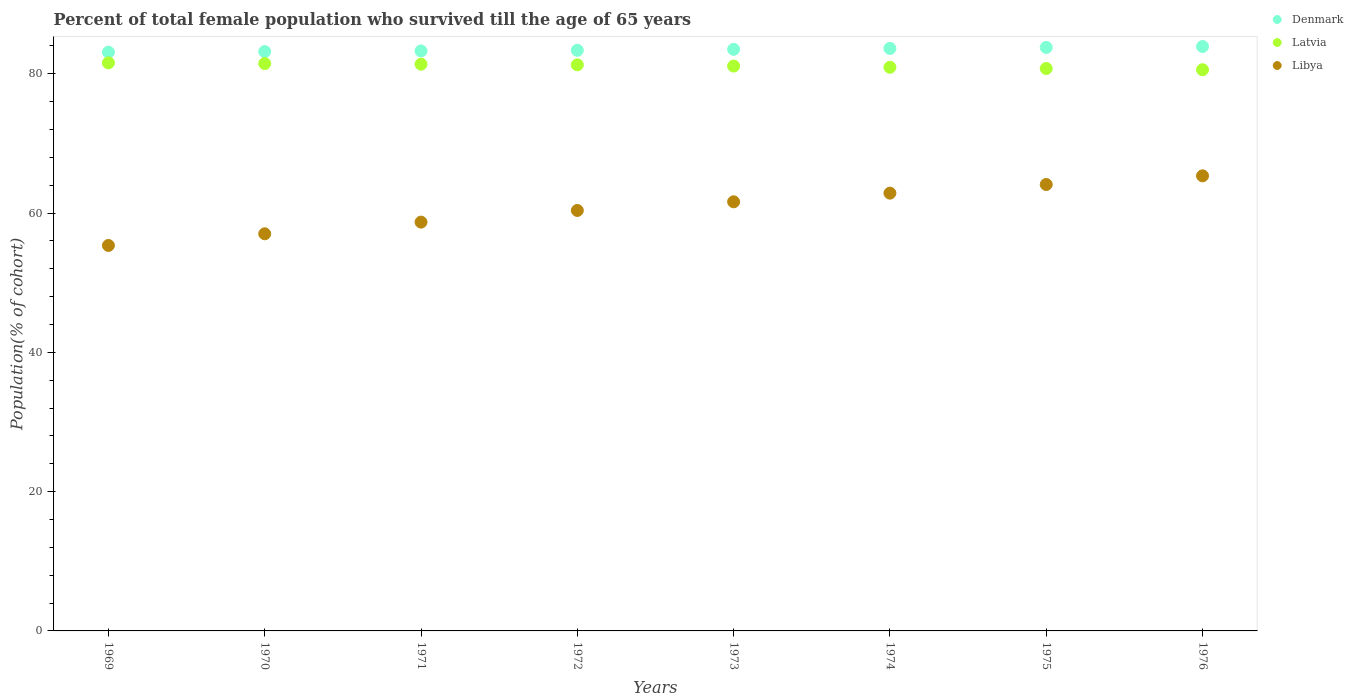What is the percentage of total female population who survived till the age of 65 years in Libya in 1971?
Offer a terse response. 58.71. Across all years, what is the maximum percentage of total female population who survived till the age of 65 years in Libya?
Provide a short and direct response. 65.35. Across all years, what is the minimum percentage of total female population who survived till the age of 65 years in Denmark?
Provide a succinct answer. 83.11. In which year was the percentage of total female population who survived till the age of 65 years in Latvia maximum?
Provide a succinct answer. 1969. In which year was the percentage of total female population who survived till the age of 65 years in Latvia minimum?
Your response must be concise. 1976. What is the total percentage of total female population who survived till the age of 65 years in Latvia in the graph?
Offer a terse response. 649.14. What is the difference between the percentage of total female population who survived till the age of 65 years in Denmark in 1974 and that in 1976?
Provide a succinct answer. -0.27. What is the difference between the percentage of total female population who survived till the age of 65 years in Latvia in 1972 and the percentage of total female population who survived till the age of 65 years in Denmark in 1970?
Your answer should be compact. -1.9. What is the average percentage of total female population who survived till the age of 65 years in Denmark per year?
Keep it short and to the point. 83.48. In the year 1973, what is the difference between the percentage of total female population who survived till the age of 65 years in Libya and percentage of total female population who survived till the age of 65 years in Denmark?
Offer a terse response. -21.89. What is the ratio of the percentage of total female population who survived till the age of 65 years in Denmark in 1973 to that in 1975?
Make the answer very short. 1. Is the percentage of total female population who survived till the age of 65 years in Denmark in 1969 less than that in 1970?
Your answer should be compact. Yes. Is the difference between the percentage of total female population who survived till the age of 65 years in Libya in 1972 and 1974 greater than the difference between the percentage of total female population who survived till the age of 65 years in Denmark in 1972 and 1974?
Ensure brevity in your answer.  No. What is the difference between the highest and the second highest percentage of total female population who survived till the age of 65 years in Denmark?
Offer a terse response. 0.14. What is the difference between the highest and the lowest percentage of total female population who survived till the age of 65 years in Denmark?
Provide a succinct answer. 0.82. In how many years, is the percentage of total female population who survived till the age of 65 years in Latvia greater than the average percentage of total female population who survived till the age of 65 years in Latvia taken over all years?
Make the answer very short. 4. Is the sum of the percentage of total female population who survived till the age of 65 years in Denmark in 1973 and 1974 greater than the maximum percentage of total female population who survived till the age of 65 years in Libya across all years?
Your answer should be compact. Yes. Does the percentage of total female population who survived till the age of 65 years in Libya monotonically increase over the years?
Make the answer very short. Yes. Is the percentage of total female population who survived till the age of 65 years in Latvia strictly less than the percentage of total female population who survived till the age of 65 years in Denmark over the years?
Offer a terse response. Yes. Are the values on the major ticks of Y-axis written in scientific E-notation?
Offer a terse response. No. Does the graph contain any zero values?
Ensure brevity in your answer.  No. Does the graph contain grids?
Ensure brevity in your answer.  No. How are the legend labels stacked?
Provide a short and direct response. Vertical. What is the title of the graph?
Offer a terse response. Percent of total female population who survived till the age of 65 years. Does "Cambodia" appear as one of the legend labels in the graph?
Your answer should be very brief. No. What is the label or title of the Y-axis?
Your answer should be very brief. Population(% of cohort). What is the Population(% of cohort) of Denmark in 1969?
Ensure brevity in your answer.  83.11. What is the Population(% of cohort) of Latvia in 1969?
Offer a terse response. 81.57. What is the Population(% of cohort) in Libya in 1969?
Keep it short and to the point. 55.36. What is the Population(% of cohort) of Denmark in 1970?
Provide a short and direct response. 83.2. What is the Population(% of cohort) in Latvia in 1970?
Offer a very short reply. 81.48. What is the Population(% of cohort) of Libya in 1970?
Offer a terse response. 57.03. What is the Population(% of cohort) of Denmark in 1971?
Offer a very short reply. 83.29. What is the Population(% of cohort) in Latvia in 1971?
Offer a terse response. 81.39. What is the Population(% of cohort) in Libya in 1971?
Keep it short and to the point. 58.71. What is the Population(% of cohort) in Denmark in 1972?
Provide a short and direct response. 83.38. What is the Population(% of cohort) of Latvia in 1972?
Your response must be concise. 81.29. What is the Population(% of cohort) of Libya in 1972?
Keep it short and to the point. 60.38. What is the Population(% of cohort) of Denmark in 1973?
Give a very brief answer. 83.52. What is the Population(% of cohort) in Latvia in 1973?
Your answer should be compact. 81.12. What is the Population(% of cohort) in Libya in 1973?
Offer a very short reply. 61.62. What is the Population(% of cohort) of Denmark in 1974?
Keep it short and to the point. 83.65. What is the Population(% of cohort) in Latvia in 1974?
Offer a very short reply. 80.94. What is the Population(% of cohort) in Libya in 1974?
Provide a short and direct response. 62.87. What is the Population(% of cohort) of Denmark in 1975?
Your answer should be compact. 83.79. What is the Population(% of cohort) of Latvia in 1975?
Offer a very short reply. 80.77. What is the Population(% of cohort) in Libya in 1975?
Offer a terse response. 64.11. What is the Population(% of cohort) of Denmark in 1976?
Your answer should be compact. 83.92. What is the Population(% of cohort) of Latvia in 1976?
Keep it short and to the point. 80.59. What is the Population(% of cohort) of Libya in 1976?
Provide a short and direct response. 65.35. Across all years, what is the maximum Population(% of cohort) of Denmark?
Your response must be concise. 83.92. Across all years, what is the maximum Population(% of cohort) of Latvia?
Offer a very short reply. 81.57. Across all years, what is the maximum Population(% of cohort) of Libya?
Offer a terse response. 65.35. Across all years, what is the minimum Population(% of cohort) in Denmark?
Ensure brevity in your answer.  83.11. Across all years, what is the minimum Population(% of cohort) of Latvia?
Provide a succinct answer. 80.59. Across all years, what is the minimum Population(% of cohort) of Libya?
Offer a very short reply. 55.36. What is the total Population(% of cohort) in Denmark in the graph?
Give a very brief answer. 667.85. What is the total Population(% of cohort) of Latvia in the graph?
Your response must be concise. 649.14. What is the total Population(% of cohort) in Libya in the graph?
Make the answer very short. 485.43. What is the difference between the Population(% of cohort) in Denmark in 1969 and that in 1970?
Keep it short and to the point. -0.09. What is the difference between the Population(% of cohort) of Latvia in 1969 and that in 1970?
Offer a very short reply. 0.09. What is the difference between the Population(% of cohort) in Libya in 1969 and that in 1970?
Make the answer very short. -1.68. What is the difference between the Population(% of cohort) in Denmark in 1969 and that in 1971?
Your answer should be very brief. -0.18. What is the difference between the Population(% of cohort) of Latvia in 1969 and that in 1971?
Your response must be concise. 0.19. What is the difference between the Population(% of cohort) in Libya in 1969 and that in 1971?
Provide a succinct answer. -3.35. What is the difference between the Population(% of cohort) of Denmark in 1969 and that in 1972?
Offer a terse response. -0.28. What is the difference between the Population(% of cohort) of Latvia in 1969 and that in 1972?
Ensure brevity in your answer.  0.28. What is the difference between the Population(% of cohort) in Libya in 1969 and that in 1972?
Your answer should be compact. -5.03. What is the difference between the Population(% of cohort) in Denmark in 1969 and that in 1973?
Your answer should be compact. -0.41. What is the difference between the Population(% of cohort) in Latvia in 1969 and that in 1973?
Provide a short and direct response. 0.45. What is the difference between the Population(% of cohort) in Libya in 1969 and that in 1973?
Make the answer very short. -6.27. What is the difference between the Population(% of cohort) of Denmark in 1969 and that in 1974?
Your response must be concise. -0.55. What is the difference between the Population(% of cohort) of Latvia in 1969 and that in 1974?
Ensure brevity in your answer.  0.63. What is the difference between the Population(% of cohort) in Libya in 1969 and that in 1974?
Ensure brevity in your answer.  -7.51. What is the difference between the Population(% of cohort) of Denmark in 1969 and that in 1975?
Offer a very short reply. -0.68. What is the difference between the Population(% of cohort) of Latvia in 1969 and that in 1975?
Keep it short and to the point. 0.8. What is the difference between the Population(% of cohort) in Libya in 1969 and that in 1975?
Make the answer very short. -8.75. What is the difference between the Population(% of cohort) of Denmark in 1969 and that in 1976?
Provide a short and direct response. -0.82. What is the difference between the Population(% of cohort) in Latvia in 1969 and that in 1976?
Make the answer very short. 0.98. What is the difference between the Population(% of cohort) of Libya in 1969 and that in 1976?
Provide a short and direct response. -10. What is the difference between the Population(% of cohort) of Denmark in 1970 and that in 1971?
Keep it short and to the point. -0.09. What is the difference between the Population(% of cohort) of Latvia in 1970 and that in 1971?
Offer a terse response. 0.09. What is the difference between the Population(% of cohort) in Libya in 1970 and that in 1971?
Ensure brevity in your answer.  -1.68. What is the difference between the Population(% of cohort) in Denmark in 1970 and that in 1972?
Your response must be concise. -0.18. What is the difference between the Population(% of cohort) in Latvia in 1970 and that in 1972?
Provide a short and direct response. 0.19. What is the difference between the Population(% of cohort) in Libya in 1970 and that in 1972?
Ensure brevity in your answer.  -3.35. What is the difference between the Population(% of cohort) of Denmark in 1970 and that in 1973?
Provide a short and direct response. -0.32. What is the difference between the Population(% of cohort) of Latvia in 1970 and that in 1973?
Ensure brevity in your answer.  0.36. What is the difference between the Population(% of cohort) of Libya in 1970 and that in 1973?
Your answer should be compact. -4.59. What is the difference between the Population(% of cohort) of Denmark in 1970 and that in 1974?
Your response must be concise. -0.46. What is the difference between the Population(% of cohort) of Latvia in 1970 and that in 1974?
Offer a terse response. 0.54. What is the difference between the Population(% of cohort) in Libya in 1970 and that in 1974?
Keep it short and to the point. -5.84. What is the difference between the Population(% of cohort) of Denmark in 1970 and that in 1975?
Provide a succinct answer. -0.59. What is the difference between the Population(% of cohort) in Latvia in 1970 and that in 1975?
Make the answer very short. 0.71. What is the difference between the Population(% of cohort) of Libya in 1970 and that in 1975?
Your answer should be very brief. -7.08. What is the difference between the Population(% of cohort) of Denmark in 1970 and that in 1976?
Provide a succinct answer. -0.73. What is the difference between the Population(% of cohort) of Latvia in 1970 and that in 1976?
Offer a very short reply. 0.89. What is the difference between the Population(% of cohort) in Libya in 1970 and that in 1976?
Make the answer very short. -8.32. What is the difference between the Population(% of cohort) of Denmark in 1971 and that in 1972?
Keep it short and to the point. -0.09. What is the difference between the Population(% of cohort) in Latvia in 1971 and that in 1972?
Ensure brevity in your answer.  0.09. What is the difference between the Population(% of cohort) in Libya in 1971 and that in 1972?
Give a very brief answer. -1.68. What is the difference between the Population(% of cohort) of Denmark in 1971 and that in 1973?
Ensure brevity in your answer.  -0.23. What is the difference between the Population(% of cohort) of Latvia in 1971 and that in 1973?
Your answer should be compact. 0.27. What is the difference between the Population(% of cohort) of Libya in 1971 and that in 1973?
Your answer should be very brief. -2.92. What is the difference between the Population(% of cohort) in Denmark in 1971 and that in 1974?
Your response must be concise. -0.36. What is the difference between the Population(% of cohort) of Latvia in 1971 and that in 1974?
Ensure brevity in your answer.  0.44. What is the difference between the Population(% of cohort) in Libya in 1971 and that in 1974?
Give a very brief answer. -4.16. What is the difference between the Population(% of cohort) in Denmark in 1971 and that in 1975?
Provide a short and direct response. -0.5. What is the difference between the Population(% of cohort) of Latvia in 1971 and that in 1975?
Offer a terse response. 0.62. What is the difference between the Population(% of cohort) of Libya in 1971 and that in 1975?
Make the answer very short. -5.4. What is the difference between the Population(% of cohort) of Denmark in 1971 and that in 1976?
Offer a very short reply. -0.63. What is the difference between the Population(% of cohort) in Latvia in 1971 and that in 1976?
Give a very brief answer. 0.79. What is the difference between the Population(% of cohort) in Libya in 1971 and that in 1976?
Give a very brief answer. -6.65. What is the difference between the Population(% of cohort) in Denmark in 1972 and that in 1973?
Your response must be concise. -0.14. What is the difference between the Population(% of cohort) in Latvia in 1972 and that in 1973?
Your response must be concise. 0.18. What is the difference between the Population(% of cohort) in Libya in 1972 and that in 1973?
Your response must be concise. -1.24. What is the difference between the Population(% of cohort) of Denmark in 1972 and that in 1974?
Give a very brief answer. -0.27. What is the difference between the Population(% of cohort) in Latvia in 1972 and that in 1974?
Provide a succinct answer. 0.35. What is the difference between the Population(% of cohort) of Libya in 1972 and that in 1974?
Keep it short and to the point. -2.49. What is the difference between the Population(% of cohort) of Denmark in 1972 and that in 1975?
Your answer should be very brief. -0.41. What is the difference between the Population(% of cohort) in Latvia in 1972 and that in 1975?
Your answer should be compact. 0.53. What is the difference between the Population(% of cohort) of Libya in 1972 and that in 1975?
Give a very brief answer. -3.73. What is the difference between the Population(% of cohort) of Denmark in 1972 and that in 1976?
Keep it short and to the point. -0.54. What is the difference between the Population(% of cohort) of Latvia in 1972 and that in 1976?
Provide a succinct answer. 0.7. What is the difference between the Population(% of cohort) of Libya in 1972 and that in 1976?
Your response must be concise. -4.97. What is the difference between the Population(% of cohort) of Denmark in 1973 and that in 1974?
Give a very brief answer. -0.14. What is the difference between the Population(% of cohort) of Latvia in 1973 and that in 1974?
Offer a very short reply. 0.18. What is the difference between the Population(% of cohort) in Libya in 1973 and that in 1974?
Keep it short and to the point. -1.24. What is the difference between the Population(% of cohort) in Denmark in 1973 and that in 1975?
Give a very brief answer. -0.27. What is the difference between the Population(% of cohort) of Latvia in 1973 and that in 1975?
Provide a succinct answer. 0.35. What is the difference between the Population(% of cohort) of Libya in 1973 and that in 1975?
Provide a short and direct response. -2.49. What is the difference between the Population(% of cohort) of Denmark in 1973 and that in 1976?
Offer a very short reply. -0.41. What is the difference between the Population(% of cohort) of Latvia in 1973 and that in 1976?
Your answer should be very brief. 0.53. What is the difference between the Population(% of cohort) of Libya in 1973 and that in 1976?
Your answer should be very brief. -3.73. What is the difference between the Population(% of cohort) of Denmark in 1974 and that in 1975?
Provide a succinct answer. -0.14. What is the difference between the Population(% of cohort) in Latvia in 1974 and that in 1975?
Make the answer very short. 0.18. What is the difference between the Population(% of cohort) in Libya in 1974 and that in 1975?
Offer a very short reply. -1.24. What is the difference between the Population(% of cohort) in Denmark in 1974 and that in 1976?
Offer a very short reply. -0.27. What is the difference between the Population(% of cohort) of Latvia in 1974 and that in 1976?
Your response must be concise. 0.35. What is the difference between the Population(% of cohort) of Libya in 1974 and that in 1976?
Your response must be concise. -2.49. What is the difference between the Population(% of cohort) in Denmark in 1975 and that in 1976?
Provide a short and direct response. -0.14. What is the difference between the Population(% of cohort) in Latvia in 1975 and that in 1976?
Ensure brevity in your answer.  0.18. What is the difference between the Population(% of cohort) in Libya in 1975 and that in 1976?
Ensure brevity in your answer.  -1.24. What is the difference between the Population(% of cohort) of Denmark in 1969 and the Population(% of cohort) of Latvia in 1970?
Give a very brief answer. 1.63. What is the difference between the Population(% of cohort) in Denmark in 1969 and the Population(% of cohort) in Libya in 1970?
Your answer should be compact. 26.07. What is the difference between the Population(% of cohort) in Latvia in 1969 and the Population(% of cohort) in Libya in 1970?
Offer a very short reply. 24.54. What is the difference between the Population(% of cohort) in Denmark in 1969 and the Population(% of cohort) in Latvia in 1971?
Provide a short and direct response. 1.72. What is the difference between the Population(% of cohort) of Denmark in 1969 and the Population(% of cohort) of Libya in 1971?
Offer a very short reply. 24.4. What is the difference between the Population(% of cohort) in Latvia in 1969 and the Population(% of cohort) in Libya in 1971?
Give a very brief answer. 22.86. What is the difference between the Population(% of cohort) of Denmark in 1969 and the Population(% of cohort) of Latvia in 1972?
Provide a short and direct response. 1.81. What is the difference between the Population(% of cohort) of Denmark in 1969 and the Population(% of cohort) of Libya in 1972?
Make the answer very short. 22.72. What is the difference between the Population(% of cohort) of Latvia in 1969 and the Population(% of cohort) of Libya in 1972?
Provide a succinct answer. 21.19. What is the difference between the Population(% of cohort) in Denmark in 1969 and the Population(% of cohort) in Latvia in 1973?
Offer a terse response. 1.99. What is the difference between the Population(% of cohort) of Denmark in 1969 and the Population(% of cohort) of Libya in 1973?
Your response must be concise. 21.48. What is the difference between the Population(% of cohort) in Latvia in 1969 and the Population(% of cohort) in Libya in 1973?
Your answer should be very brief. 19.95. What is the difference between the Population(% of cohort) in Denmark in 1969 and the Population(% of cohort) in Latvia in 1974?
Offer a terse response. 2.16. What is the difference between the Population(% of cohort) of Denmark in 1969 and the Population(% of cohort) of Libya in 1974?
Provide a short and direct response. 20.24. What is the difference between the Population(% of cohort) of Latvia in 1969 and the Population(% of cohort) of Libya in 1974?
Provide a short and direct response. 18.7. What is the difference between the Population(% of cohort) of Denmark in 1969 and the Population(% of cohort) of Latvia in 1975?
Provide a succinct answer. 2.34. What is the difference between the Population(% of cohort) in Denmark in 1969 and the Population(% of cohort) in Libya in 1975?
Provide a succinct answer. 19. What is the difference between the Population(% of cohort) of Latvia in 1969 and the Population(% of cohort) of Libya in 1975?
Give a very brief answer. 17.46. What is the difference between the Population(% of cohort) of Denmark in 1969 and the Population(% of cohort) of Latvia in 1976?
Offer a terse response. 2.51. What is the difference between the Population(% of cohort) of Denmark in 1969 and the Population(% of cohort) of Libya in 1976?
Your answer should be compact. 17.75. What is the difference between the Population(% of cohort) in Latvia in 1969 and the Population(% of cohort) in Libya in 1976?
Make the answer very short. 16.22. What is the difference between the Population(% of cohort) of Denmark in 1970 and the Population(% of cohort) of Latvia in 1971?
Your response must be concise. 1.81. What is the difference between the Population(% of cohort) of Denmark in 1970 and the Population(% of cohort) of Libya in 1971?
Provide a succinct answer. 24.49. What is the difference between the Population(% of cohort) in Latvia in 1970 and the Population(% of cohort) in Libya in 1971?
Ensure brevity in your answer.  22.77. What is the difference between the Population(% of cohort) of Denmark in 1970 and the Population(% of cohort) of Latvia in 1972?
Your response must be concise. 1.9. What is the difference between the Population(% of cohort) of Denmark in 1970 and the Population(% of cohort) of Libya in 1972?
Provide a short and direct response. 22.82. What is the difference between the Population(% of cohort) in Latvia in 1970 and the Population(% of cohort) in Libya in 1972?
Keep it short and to the point. 21.1. What is the difference between the Population(% of cohort) of Denmark in 1970 and the Population(% of cohort) of Latvia in 1973?
Give a very brief answer. 2.08. What is the difference between the Population(% of cohort) in Denmark in 1970 and the Population(% of cohort) in Libya in 1973?
Your answer should be compact. 21.57. What is the difference between the Population(% of cohort) in Latvia in 1970 and the Population(% of cohort) in Libya in 1973?
Keep it short and to the point. 19.85. What is the difference between the Population(% of cohort) in Denmark in 1970 and the Population(% of cohort) in Latvia in 1974?
Keep it short and to the point. 2.25. What is the difference between the Population(% of cohort) of Denmark in 1970 and the Population(% of cohort) of Libya in 1974?
Your response must be concise. 20.33. What is the difference between the Population(% of cohort) in Latvia in 1970 and the Population(% of cohort) in Libya in 1974?
Give a very brief answer. 18.61. What is the difference between the Population(% of cohort) of Denmark in 1970 and the Population(% of cohort) of Latvia in 1975?
Your answer should be very brief. 2.43. What is the difference between the Population(% of cohort) of Denmark in 1970 and the Population(% of cohort) of Libya in 1975?
Provide a succinct answer. 19.09. What is the difference between the Population(% of cohort) of Latvia in 1970 and the Population(% of cohort) of Libya in 1975?
Ensure brevity in your answer.  17.37. What is the difference between the Population(% of cohort) in Denmark in 1970 and the Population(% of cohort) in Latvia in 1976?
Offer a terse response. 2.61. What is the difference between the Population(% of cohort) of Denmark in 1970 and the Population(% of cohort) of Libya in 1976?
Provide a succinct answer. 17.84. What is the difference between the Population(% of cohort) of Latvia in 1970 and the Population(% of cohort) of Libya in 1976?
Ensure brevity in your answer.  16.12. What is the difference between the Population(% of cohort) in Denmark in 1971 and the Population(% of cohort) in Latvia in 1972?
Ensure brevity in your answer.  2. What is the difference between the Population(% of cohort) in Denmark in 1971 and the Population(% of cohort) in Libya in 1972?
Your answer should be compact. 22.91. What is the difference between the Population(% of cohort) in Latvia in 1971 and the Population(% of cohort) in Libya in 1972?
Your response must be concise. 21. What is the difference between the Population(% of cohort) of Denmark in 1971 and the Population(% of cohort) of Latvia in 1973?
Ensure brevity in your answer.  2.17. What is the difference between the Population(% of cohort) of Denmark in 1971 and the Population(% of cohort) of Libya in 1973?
Ensure brevity in your answer.  21.66. What is the difference between the Population(% of cohort) in Latvia in 1971 and the Population(% of cohort) in Libya in 1973?
Ensure brevity in your answer.  19.76. What is the difference between the Population(% of cohort) of Denmark in 1971 and the Population(% of cohort) of Latvia in 1974?
Ensure brevity in your answer.  2.35. What is the difference between the Population(% of cohort) in Denmark in 1971 and the Population(% of cohort) in Libya in 1974?
Your answer should be very brief. 20.42. What is the difference between the Population(% of cohort) in Latvia in 1971 and the Population(% of cohort) in Libya in 1974?
Offer a very short reply. 18.52. What is the difference between the Population(% of cohort) of Denmark in 1971 and the Population(% of cohort) of Latvia in 1975?
Ensure brevity in your answer.  2.52. What is the difference between the Population(% of cohort) in Denmark in 1971 and the Population(% of cohort) in Libya in 1975?
Your answer should be very brief. 19.18. What is the difference between the Population(% of cohort) of Latvia in 1971 and the Population(% of cohort) of Libya in 1975?
Keep it short and to the point. 17.28. What is the difference between the Population(% of cohort) of Denmark in 1971 and the Population(% of cohort) of Latvia in 1976?
Keep it short and to the point. 2.7. What is the difference between the Population(% of cohort) of Denmark in 1971 and the Population(% of cohort) of Libya in 1976?
Your answer should be compact. 17.94. What is the difference between the Population(% of cohort) in Latvia in 1971 and the Population(% of cohort) in Libya in 1976?
Keep it short and to the point. 16.03. What is the difference between the Population(% of cohort) in Denmark in 1972 and the Population(% of cohort) in Latvia in 1973?
Keep it short and to the point. 2.26. What is the difference between the Population(% of cohort) of Denmark in 1972 and the Population(% of cohort) of Libya in 1973?
Your answer should be compact. 21.76. What is the difference between the Population(% of cohort) of Latvia in 1972 and the Population(% of cohort) of Libya in 1973?
Your answer should be compact. 19.67. What is the difference between the Population(% of cohort) in Denmark in 1972 and the Population(% of cohort) in Latvia in 1974?
Keep it short and to the point. 2.44. What is the difference between the Population(% of cohort) in Denmark in 1972 and the Population(% of cohort) in Libya in 1974?
Make the answer very short. 20.51. What is the difference between the Population(% of cohort) of Latvia in 1972 and the Population(% of cohort) of Libya in 1974?
Your answer should be very brief. 18.43. What is the difference between the Population(% of cohort) of Denmark in 1972 and the Population(% of cohort) of Latvia in 1975?
Provide a short and direct response. 2.61. What is the difference between the Population(% of cohort) of Denmark in 1972 and the Population(% of cohort) of Libya in 1975?
Ensure brevity in your answer.  19.27. What is the difference between the Population(% of cohort) in Latvia in 1972 and the Population(% of cohort) in Libya in 1975?
Make the answer very short. 17.18. What is the difference between the Population(% of cohort) in Denmark in 1972 and the Population(% of cohort) in Latvia in 1976?
Your answer should be very brief. 2.79. What is the difference between the Population(% of cohort) of Denmark in 1972 and the Population(% of cohort) of Libya in 1976?
Provide a short and direct response. 18.03. What is the difference between the Population(% of cohort) of Latvia in 1972 and the Population(% of cohort) of Libya in 1976?
Offer a terse response. 15.94. What is the difference between the Population(% of cohort) of Denmark in 1973 and the Population(% of cohort) of Latvia in 1974?
Your answer should be very brief. 2.57. What is the difference between the Population(% of cohort) of Denmark in 1973 and the Population(% of cohort) of Libya in 1974?
Your response must be concise. 20.65. What is the difference between the Population(% of cohort) of Latvia in 1973 and the Population(% of cohort) of Libya in 1974?
Make the answer very short. 18.25. What is the difference between the Population(% of cohort) of Denmark in 1973 and the Population(% of cohort) of Latvia in 1975?
Ensure brevity in your answer.  2.75. What is the difference between the Population(% of cohort) in Denmark in 1973 and the Population(% of cohort) in Libya in 1975?
Keep it short and to the point. 19.41. What is the difference between the Population(% of cohort) in Latvia in 1973 and the Population(% of cohort) in Libya in 1975?
Offer a terse response. 17.01. What is the difference between the Population(% of cohort) in Denmark in 1973 and the Population(% of cohort) in Latvia in 1976?
Your response must be concise. 2.92. What is the difference between the Population(% of cohort) in Denmark in 1973 and the Population(% of cohort) in Libya in 1976?
Provide a succinct answer. 18.16. What is the difference between the Population(% of cohort) in Latvia in 1973 and the Population(% of cohort) in Libya in 1976?
Provide a short and direct response. 15.76. What is the difference between the Population(% of cohort) of Denmark in 1974 and the Population(% of cohort) of Latvia in 1975?
Ensure brevity in your answer.  2.89. What is the difference between the Population(% of cohort) of Denmark in 1974 and the Population(% of cohort) of Libya in 1975?
Make the answer very short. 19.54. What is the difference between the Population(% of cohort) in Latvia in 1974 and the Population(% of cohort) in Libya in 1975?
Keep it short and to the point. 16.83. What is the difference between the Population(% of cohort) in Denmark in 1974 and the Population(% of cohort) in Latvia in 1976?
Ensure brevity in your answer.  3.06. What is the difference between the Population(% of cohort) in Denmark in 1974 and the Population(% of cohort) in Libya in 1976?
Offer a very short reply. 18.3. What is the difference between the Population(% of cohort) of Latvia in 1974 and the Population(% of cohort) of Libya in 1976?
Keep it short and to the point. 15.59. What is the difference between the Population(% of cohort) in Denmark in 1975 and the Population(% of cohort) in Latvia in 1976?
Provide a succinct answer. 3.2. What is the difference between the Population(% of cohort) of Denmark in 1975 and the Population(% of cohort) of Libya in 1976?
Ensure brevity in your answer.  18.43. What is the difference between the Population(% of cohort) in Latvia in 1975 and the Population(% of cohort) in Libya in 1976?
Your answer should be very brief. 15.41. What is the average Population(% of cohort) of Denmark per year?
Make the answer very short. 83.48. What is the average Population(% of cohort) in Latvia per year?
Provide a succinct answer. 81.14. What is the average Population(% of cohort) in Libya per year?
Ensure brevity in your answer.  60.68. In the year 1969, what is the difference between the Population(% of cohort) of Denmark and Population(% of cohort) of Latvia?
Give a very brief answer. 1.53. In the year 1969, what is the difference between the Population(% of cohort) in Denmark and Population(% of cohort) in Libya?
Provide a short and direct response. 27.75. In the year 1969, what is the difference between the Population(% of cohort) of Latvia and Population(% of cohort) of Libya?
Offer a very short reply. 26.22. In the year 1970, what is the difference between the Population(% of cohort) of Denmark and Population(% of cohort) of Latvia?
Offer a very short reply. 1.72. In the year 1970, what is the difference between the Population(% of cohort) of Denmark and Population(% of cohort) of Libya?
Offer a terse response. 26.17. In the year 1970, what is the difference between the Population(% of cohort) in Latvia and Population(% of cohort) in Libya?
Your answer should be very brief. 24.45. In the year 1971, what is the difference between the Population(% of cohort) of Denmark and Population(% of cohort) of Latvia?
Keep it short and to the point. 1.9. In the year 1971, what is the difference between the Population(% of cohort) in Denmark and Population(% of cohort) in Libya?
Your answer should be compact. 24.58. In the year 1971, what is the difference between the Population(% of cohort) in Latvia and Population(% of cohort) in Libya?
Offer a terse response. 22.68. In the year 1972, what is the difference between the Population(% of cohort) in Denmark and Population(% of cohort) in Latvia?
Offer a terse response. 2.09. In the year 1972, what is the difference between the Population(% of cohort) of Denmark and Population(% of cohort) of Libya?
Keep it short and to the point. 23. In the year 1972, what is the difference between the Population(% of cohort) of Latvia and Population(% of cohort) of Libya?
Your answer should be compact. 20.91. In the year 1973, what is the difference between the Population(% of cohort) in Denmark and Population(% of cohort) in Latvia?
Give a very brief answer. 2.4. In the year 1973, what is the difference between the Population(% of cohort) of Denmark and Population(% of cohort) of Libya?
Your answer should be very brief. 21.89. In the year 1973, what is the difference between the Population(% of cohort) in Latvia and Population(% of cohort) in Libya?
Ensure brevity in your answer.  19.49. In the year 1974, what is the difference between the Population(% of cohort) in Denmark and Population(% of cohort) in Latvia?
Make the answer very short. 2.71. In the year 1974, what is the difference between the Population(% of cohort) in Denmark and Population(% of cohort) in Libya?
Keep it short and to the point. 20.79. In the year 1974, what is the difference between the Population(% of cohort) in Latvia and Population(% of cohort) in Libya?
Provide a succinct answer. 18.07. In the year 1975, what is the difference between the Population(% of cohort) of Denmark and Population(% of cohort) of Latvia?
Offer a terse response. 3.02. In the year 1975, what is the difference between the Population(% of cohort) in Denmark and Population(% of cohort) in Libya?
Give a very brief answer. 19.68. In the year 1975, what is the difference between the Population(% of cohort) of Latvia and Population(% of cohort) of Libya?
Your response must be concise. 16.66. In the year 1976, what is the difference between the Population(% of cohort) in Denmark and Population(% of cohort) in Latvia?
Provide a short and direct response. 3.33. In the year 1976, what is the difference between the Population(% of cohort) of Denmark and Population(% of cohort) of Libya?
Your answer should be compact. 18.57. In the year 1976, what is the difference between the Population(% of cohort) of Latvia and Population(% of cohort) of Libya?
Give a very brief answer. 15.24. What is the ratio of the Population(% of cohort) of Denmark in 1969 to that in 1970?
Offer a terse response. 1. What is the ratio of the Population(% of cohort) in Latvia in 1969 to that in 1970?
Provide a succinct answer. 1. What is the ratio of the Population(% of cohort) of Libya in 1969 to that in 1970?
Offer a very short reply. 0.97. What is the ratio of the Population(% of cohort) of Denmark in 1969 to that in 1971?
Offer a very short reply. 1. What is the ratio of the Population(% of cohort) of Latvia in 1969 to that in 1971?
Your answer should be compact. 1. What is the ratio of the Population(% of cohort) of Libya in 1969 to that in 1971?
Your answer should be compact. 0.94. What is the ratio of the Population(% of cohort) in Libya in 1969 to that in 1972?
Offer a terse response. 0.92. What is the ratio of the Population(% of cohort) in Denmark in 1969 to that in 1973?
Your response must be concise. 1. What is the ratio of the Population(% of cohort) in Latvia in 1969 to that in 1973?
Your answer should be compact. 1.01. What is the ratio of the Population(% of cohort) of Libya in 1969 to that in 1973?
Offer a terse response. 0.9. What is the ratio of the Population(% of cohort) of Denmark in 1969 to that in 1974?
Provide a short and direct response. 0.99. What is the ratio of the Population(% of cohort) of Latvia in 1969 to that in 1974?
Your answer should be compact. 1.01. What is the ratio of the Population(% of cohort) in Libya in 1969 to that in 1974?
Ensure brevity in your answer.  0.88. What is the ratio of the Population(% of cohort) in Libya in 1969 to that in 1975?
Your response must be concise. 0.86. What is the ratio of the Population(% of cohort) in Denmark in 1969 to that in 1976?
Your response must be concise. 0.99. What is the ratio of the Population(% of cohort) of Latvia in 1969 to that in 1976?
Provide a succinct answer. 1.01. What is the ratio of the Population(% of cohort) in Libya in 1969 to that in 1976?
Ensure brevity in your answer.  0.85. What is the ratio of the Population(% of cohort) in Denmark in 1970 to that in 1971?
Your answer should be compact. 1. What is the ratio of the Population(% of cohort) of Libya in 1970 to that in 1971?
Provide a succinct answer. 0.97. What is the ratio of the Population(% of cohort) in Denmark in 1970 to that in 1972?
Provide a succinct answer. 1. What is the ratio of the Population(% of cohort) in Libya in 1970 to that in 1972?
Offer a terse response. 0.94. What is the ratio of the Population(% of cohort) in Latvia in 1970 to that in 1973?
Make the answer very short. 1. What is the ratio of the Population(% of cohort) of Libya in 1970 to that in 1973?
Offer a very short reply. 0.93. What is the ratio of the Population(% of cohort) of Latvia in 1970 to that in 1974?
Your response must be concise. 1.01. What is the ratio of the Population(% of cohort) in Libya in 1970 to that in 1974?
Offer a terse response. 0.91. What is the ratio of the Population(% of cohort) of Denmark in 1970 to that in 1975?
Ensure brevity in your answer.  0.99. What is the ratio of the Population(% of cohort) of Latvia in 1970 to that in 1975?
Provide a short and direct response. 1.01. What is the ratio of the Population(% of cohort) of Libya in 1970 to that in 1975?
Give a very brief answer. 0.89. What is the ratio of the Population(% of cohort) in Denmark in 1970 to that in 1976?
Provide a short and direct response. 0.99. What is the ratio of the Population(% of cohort) of Libya in 1970 to that in 1976?
Ensure brevity in your answer.  0.87. What is the ratio of the Population(% of cohort) in Denmark in 1971 to that in 1972?
Offer a terse response. 1. What is the ratio of the Population(% of cohort) in Libya in 1971 to that in 1972?
Your answer should be compact. 0.97. What is the ratio of the Population(% of cohort) of Denmark in 1971 to that in 1973?
Offer a very short reply. 1. What is the ratio of the Population(% of cohort) of Latvia in 1971 to that in 1973?
Your answer should be compact. 1. What is the ratio of the Population(% of cohort) of Libya in 1971 to that in 1973?
Make the answer very short. 0.95. What is the ratio of the Population(% of cohort) of Latvia in 1971 to that in 1974?
Your answer should be compact. 1.01. What is the ratio of the Population(% of cohort) of Libya in 1971 to that in 1974?
Offer a very short reply. 0.93. What is the ratio of the Population(% of cohort) in Latvia in 1971 to that in 1975?
Ensure brevity in your answer.  1.01. What is the ratio of the Population(% of cohort) of Libya in 1971 to that in 1975?
Offer a very short reply. 0.92. What is the ratio of the Population(% of cohort) of Latvia in 1971 to that in 1976?
Give a very brief answer. 1.01. What is the ratio of the Population(% of cohort) of Libya in 1971 to that in 1976?
Offer a very short reply. 0.9. What is the ratio of the Population(% of cohort) of Libya in 1972 to that in 1973?
Your answer should be very brief. 0.98. What is the ratio of the Population(% of cohort) in Latvia in 1972 to that in 1974?
Provide a short and direct response. 1. What is the ratio of the Population(% of cohort) of Libya in 1972 to that in 1974?
Provide a short and direct response. 0.96. What is the ratio of the Population(% of cohort) of Libya in 1972 to that in 1975?
Provide a short and direct response. 0.94. What is the ratio of the Population(% of cohort) in Denmark in 1972 to that in 1976?
Provide a succinct answer. 0.99. What is the ratio of the Population(% of cohort) of Latvia in 1972 to that in 1976?
Offer a very short reply. 1.01. What is the ratio of the Population(% of cohort) in Libya in 1972 to that in 1976?
Ensure brevity in your answer.  0.92. What is the ratio of the Population(% of cohort) in Latvia in 1973 to that in 1974?
Keep it short and to the point. 1. What is the ratio of the Population(% of cohort) of Libya in 1973 to that in 1974?
Provide a succinct answer. 0.98. What is the ratio of the Population(% of cohort) in Denmark in 1973 to that in 1975?
Give a very brief answer. 1. What is the ratio of the Population(% of cohort) of Libya in 1973 to that in 1975?
Ensure brevity in your answer.  0.96. What is the ratio of the Population(% of cohort) in Denmark in 1973 to that in 1976?
Your answer should be compact. 1. What is the ratio of the Population(% of cohort) in Libya in 1973 to that in 1976?
Provide a short and direct response. 0.94. What is the ratio of the Population(% of cohort) of Latvia in 1974 to that in 1975?
Your answer should be compact. 1. What is the ratio of the Population(% of cohort) of Libya in 1974 to that in 1975?
Keep it short and to the point. 0.98. What is the ratio of the Population(% of cohort) of Latvia in 1974 to that in 1976?
Give a very brief answer. 1. What is the ratio of the Population(% of cohort) of Libya in 1974 to that in 1976?
Your answer should be compact. 0.96. What is the ratio of the Population(% of cohort) of Denmark in 1975 to that in 1976?
Provide a succinct answer. 1. What is the ratio of the Population(% of cohort) in Latvia in 1975 to that in 1976?
Provide a succinct answer. 1. What is the difference between the highest and the second highest Population(% of cohort) of Denmark?
Keep it short and to the point. 0.14. What is the difference between the highest and the second highest Population(% of cohort) of Latvia?
Your answer should be compact. 0.09. What is the difference between the highest and the second highest Population(% of cohort) in Libya?
Your answer should be very brief. 1.24. What is the difference between the highest and the lowest Population(% of cohort) of Denmark?
Provide a short and direct response. 0.82. What is the difference between the highest and the lowest Population(% of cohort) of Latvia?
Provide a short and direct response. 0.98. What is the difference between the highest and the lowest Population(% of cohort) in Libya?
Make the answer very short. 10. 